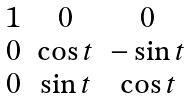Convert formula to latex. <formula><loc_0><loc_0><loc_500><loc_500>\begin{matrix} 1 & 0 & 0 \\ 0 & \cos { t } & - \sin { t } \\ 0 & \sin { t } & \cos { t } \end{matrix}</formula> 